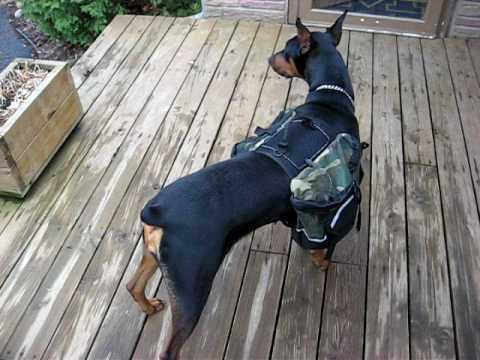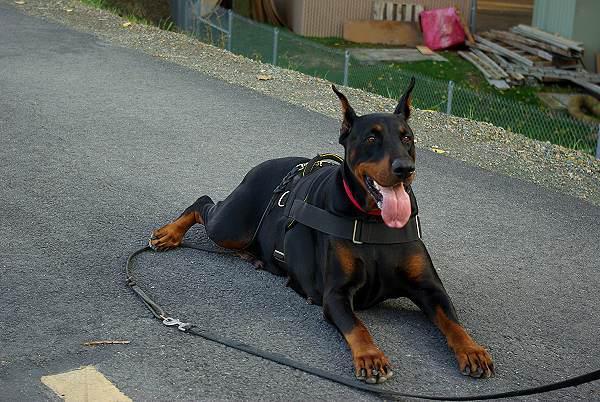The first image is the image on the left, the second image is the image on the right. For the images shown, is this caption "A man with a backpack is standing with a dog in the image on the left." true? Answer yes or no. No. 